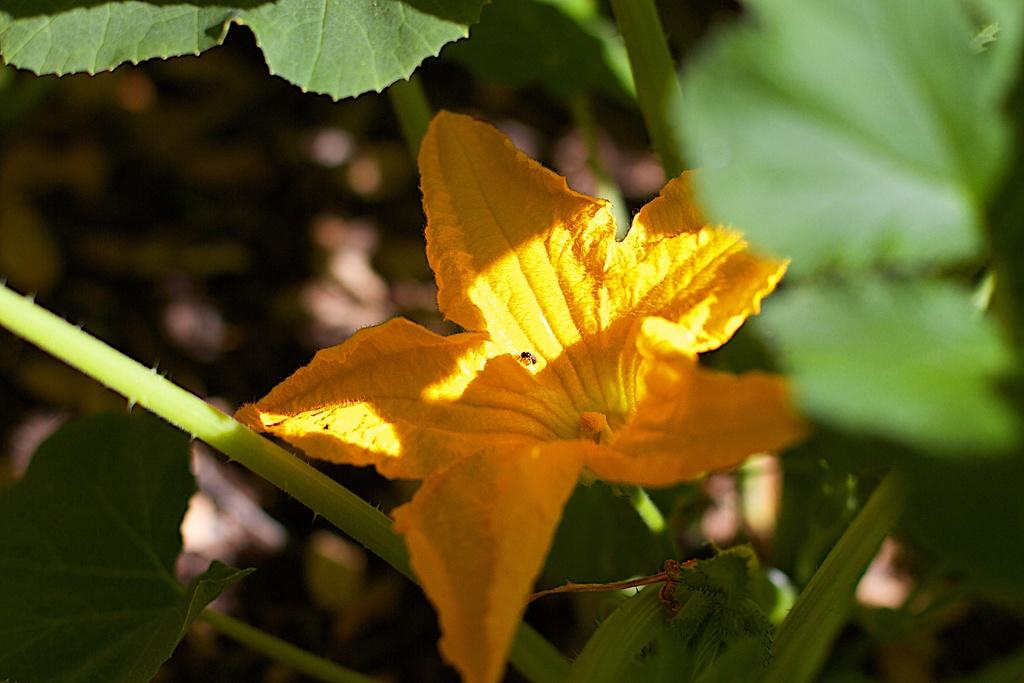What is the main subject of the image? There is a flower in the center of the image. What other parts of the plant can be seen in the image? The image contains leaves and stems of a plant. How would you describe the background of the image? The background of the image is blurred. What type of event is taking place in the image? There is no event taking place in the image; it is a still image of a flower, leaves, and stems. Can you identify the writer of the image? There is no writer associated with the image; it is a photograph or illustration of a plant. 